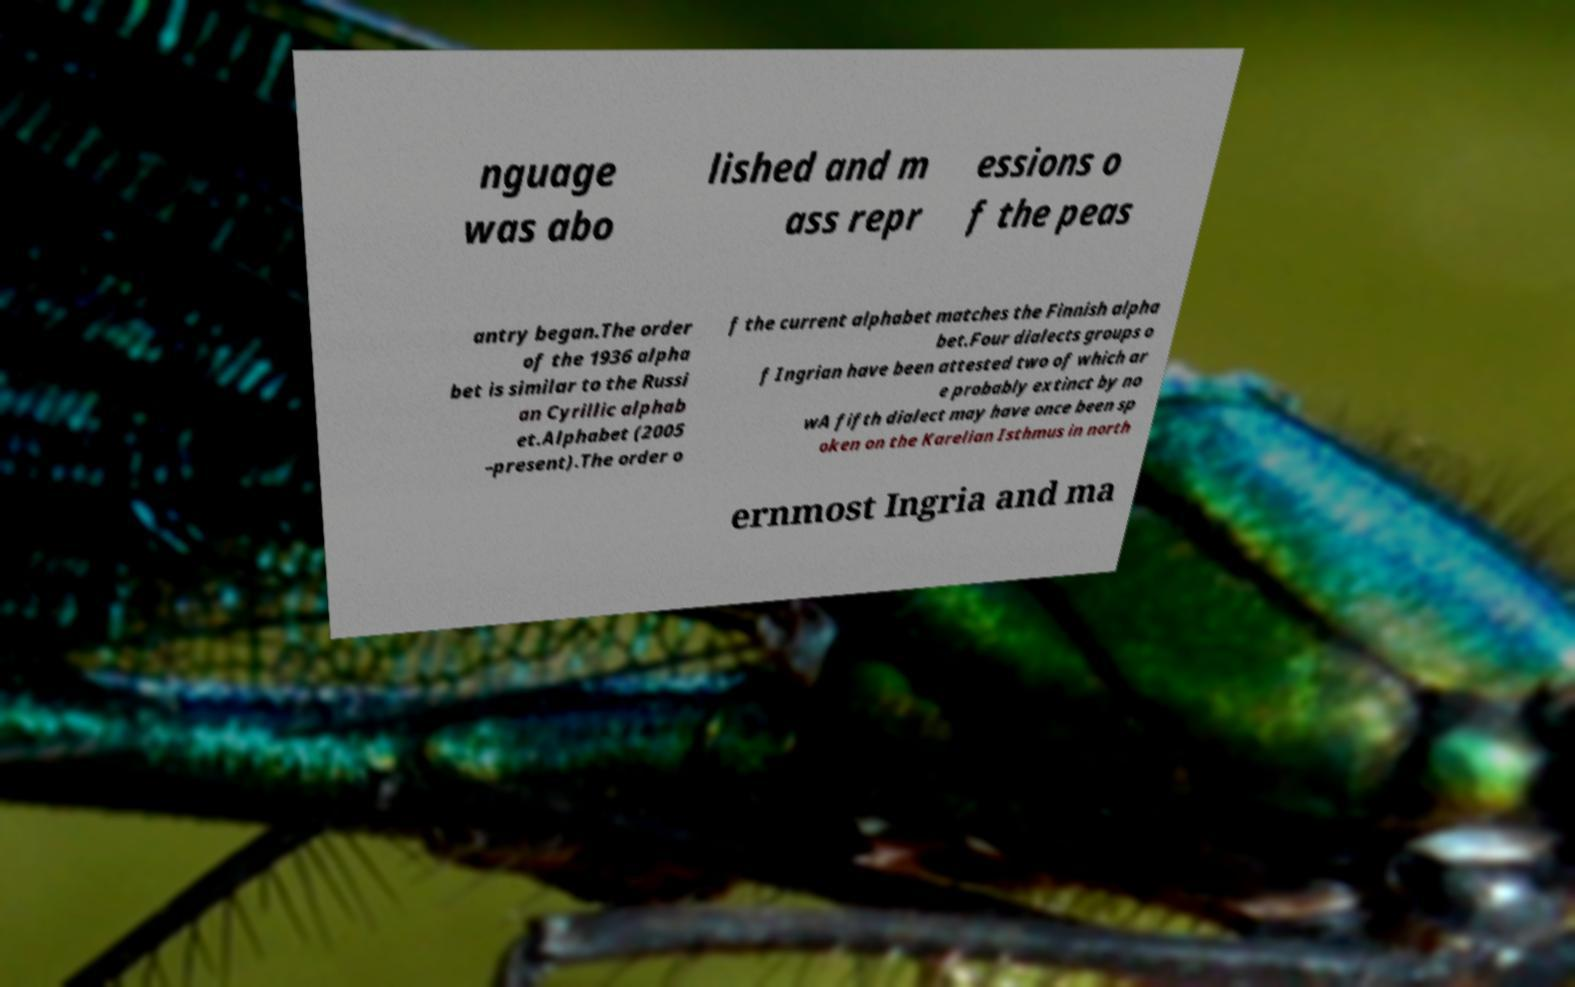Can you accurately transcribe the text from the provided image for me? nguage was abo lished and m ass repr essions o f the peas antry began.The order of the 1936 alpha bet is similar to the Russi an Cyrillic alphab et.Alphabet (2005 –present).The order o f the current alphabet matches the Finnish alpha bet.Four dialects groups o f Ingrian have been attested two of which ar e probably extinct by no wA fifth dialect may have once been sp oken on the Karelian Isthmus in north ernmost Ingria and ma 